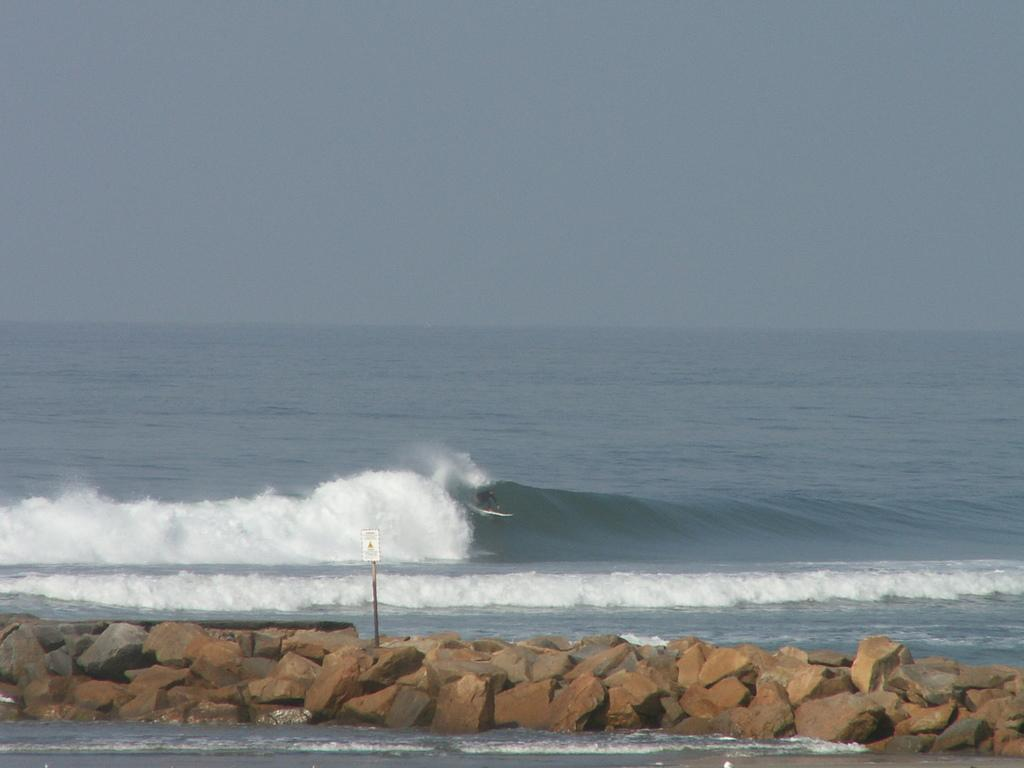What is the main object in the image? There is a white color board in the image. How is the color board supported? The board is attached to a pole. What is the pole resting on? The pole is on rocks. What can be seen in the background of the image? There is water and the sky visible in the background of the image. How many apples are on the color board in the image? There are no apples present on the color board in the image. What type of crack can be seen on the color board in the image? There is no crack visible on the color board in the image. 